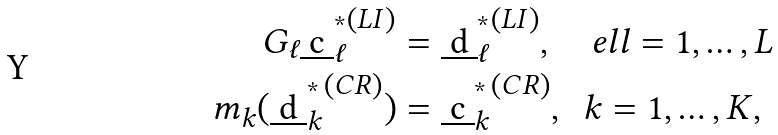<formula> <loc_0><loc_0><loc_500><loc_500>G _ { \ell } { \underbar { c } ^ { ^ { * } } _ { \ell } } ^ { ( L I ) } & = { \underbar { d } ^ { ^ { * } } _ { \ell } } ^ { ( L I ) } , \quad e l l = 1 , \dots , L \\ m _ { k } ( { \underbar { d } ^ { ^ { * } } _ { k } } ^ { ( C R ) } ) & = { \underbar { c } ^ { ^ { * } } _ { k } } ^ { ( C R ) } , \ \ k = 1 , \dots , K ,</formula> 